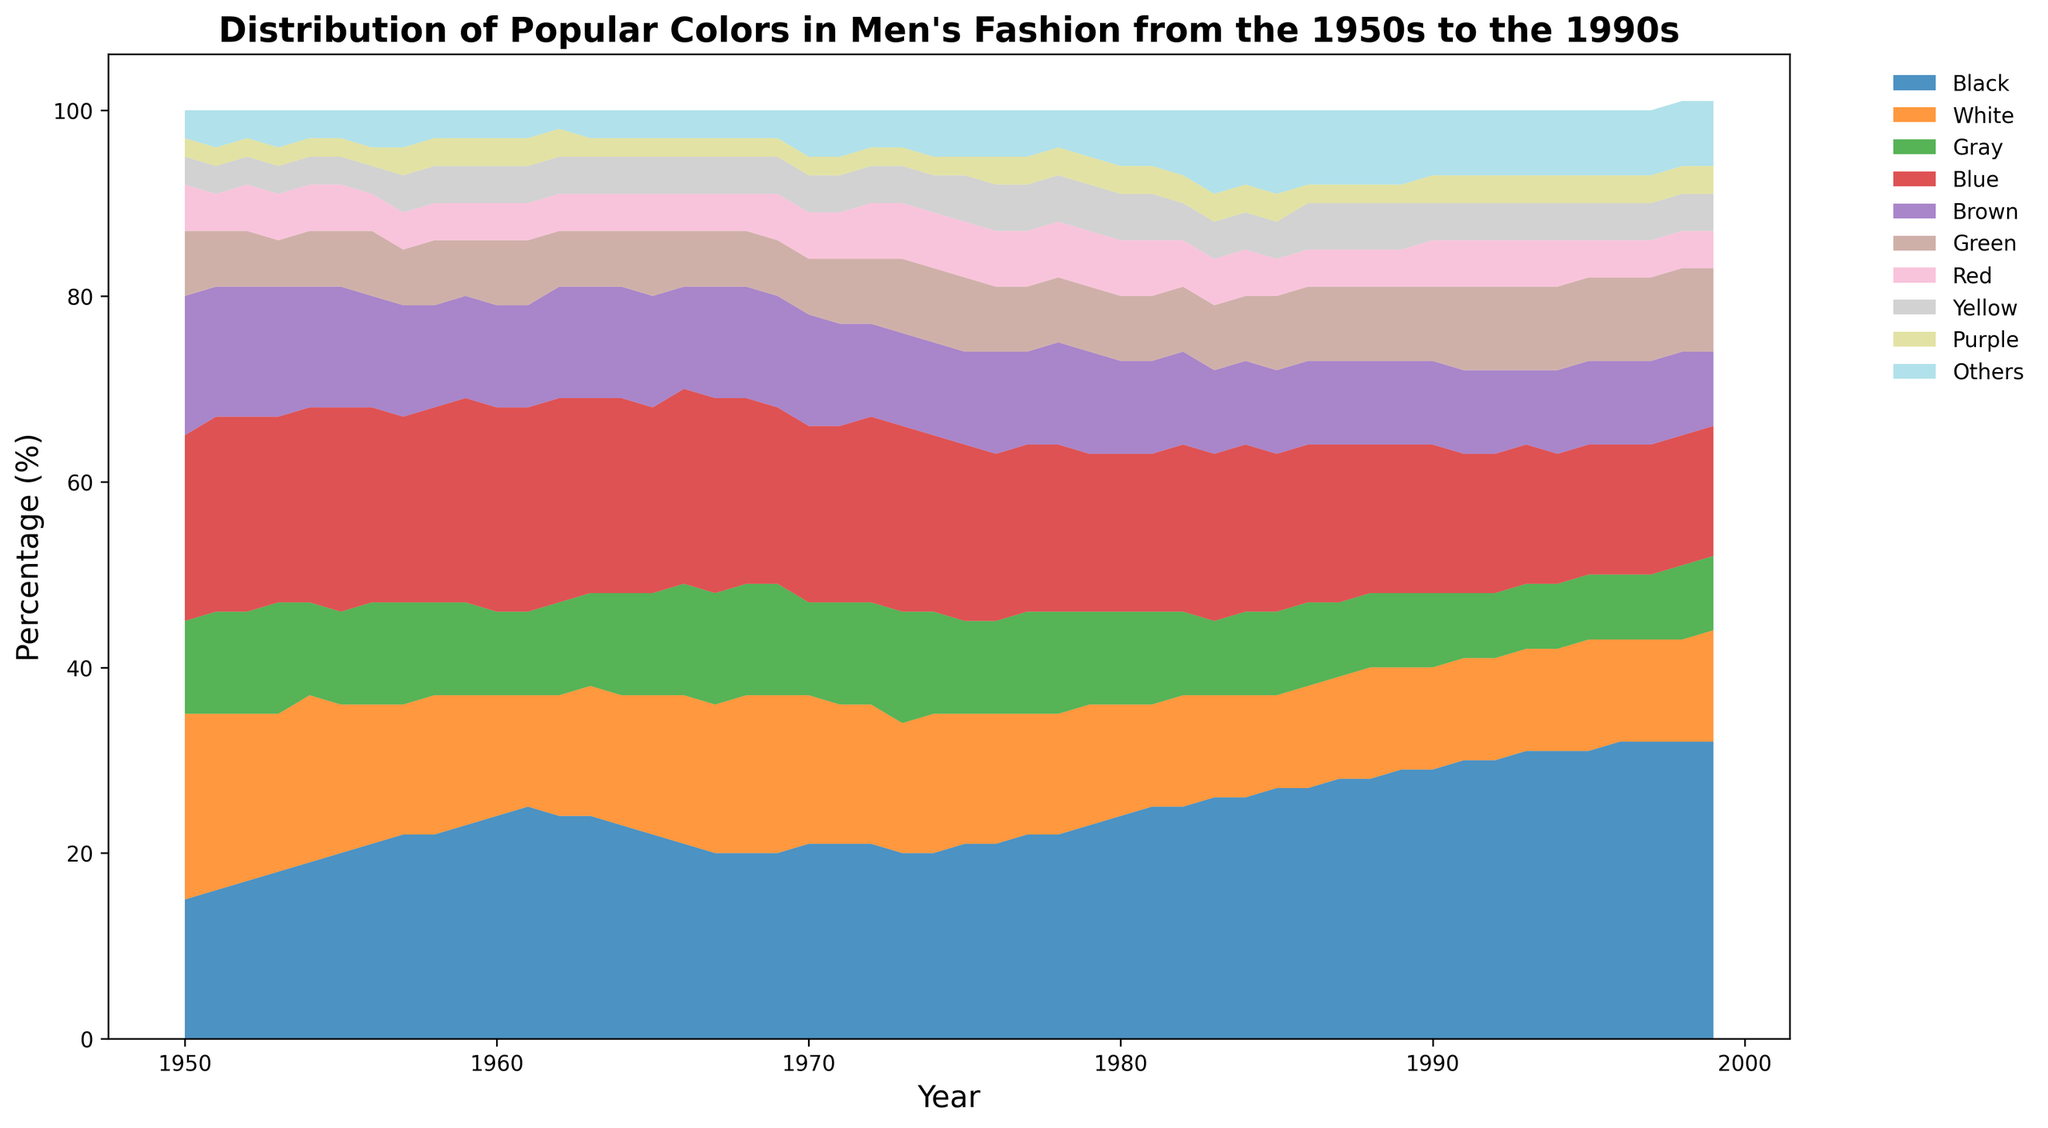What's the dominant color in men's fashion throughout the 1990s? To determine the dominant color, look at the highest area section in the plot for the 1990s. Notice that the black area is consistently highest.
Answer: Black Which decade saw the largest increase in the popularity of black clothing? Compare the starting and ending percentages of black in each decade. The largest increase occurs between 1950 and 1960, from 15% to 24%, an increase of 9%.
Answer: 1950s How did the popularity of gray change from the 1950s to the 1990s? Observe the gray area throughout the years. In the 1950s, gray starts at 10%, while in the 1990s, it ranges around 7-8%. There’s a decrease from the 1950s to 1990s.
Answer: Decrease Which color shows a notable increase around the 1980s? Focus on the height change in the plot for each color around the 1980s. Green shows a visible increase.
Answer: Green What two colors jointly gained popularity between 1980 and 1990? Look at the sections that increased in area during this period. Both black and green increased their share noticeably.
Answer: Black and Green By how many percentage points did the popularity of white change from 1950 to 1999? Start with 20% in 1950 and note 12% in 1999. Calculate the difference, which is 20% - 12% = 8% drop.
Answer: 8% drop Comparing the 1970s to the 1980s, did blue’s popularity increase or decrease? Observe the blue area, starting close to 19-20% in 1970 and dropping to about 17-18% in 1980.
Answer: Decrease How did the popularity of "Others" trend throughout the time period? Look at the "Others" area plot from 1950 to 1999, which gradually increases, especially visibly in the latter decades.
Answer: Increase During which decade did red reach its peak popularity? Examine the height of the red section in each decade. Red is at its peak around the 1970s.
Answer: 1970s Is there a color that consistently shows low popularity throughout the 1950s to 1990s? Identify any color sections that stay small. Purple and Yellow maintain consistently low shares.
Answer: Purple or Yellow 